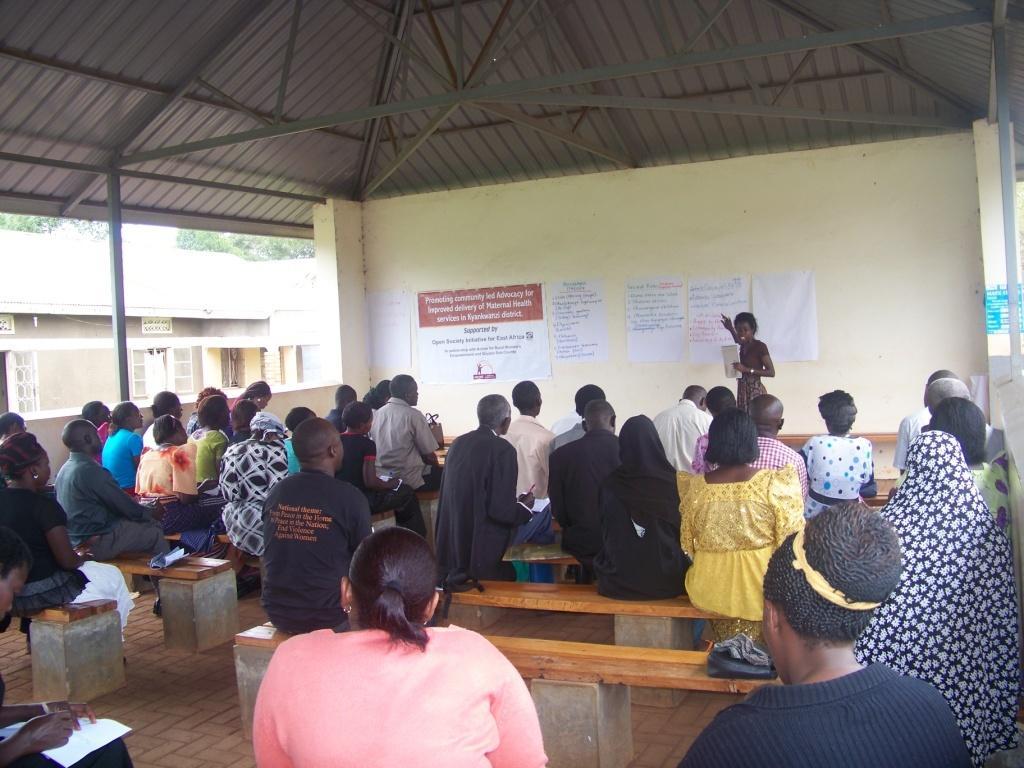In one or two sentences, can you explain what this image depicts? In this image I can see the group of people sitting on the benches. I can see one person is holding the pen and the book. In the back another person is standing and holding another paper. I can also see some papers to the wall. These people are under the shed. To the left I can see the house and the trees. And these people are wearing the different color dresses. 